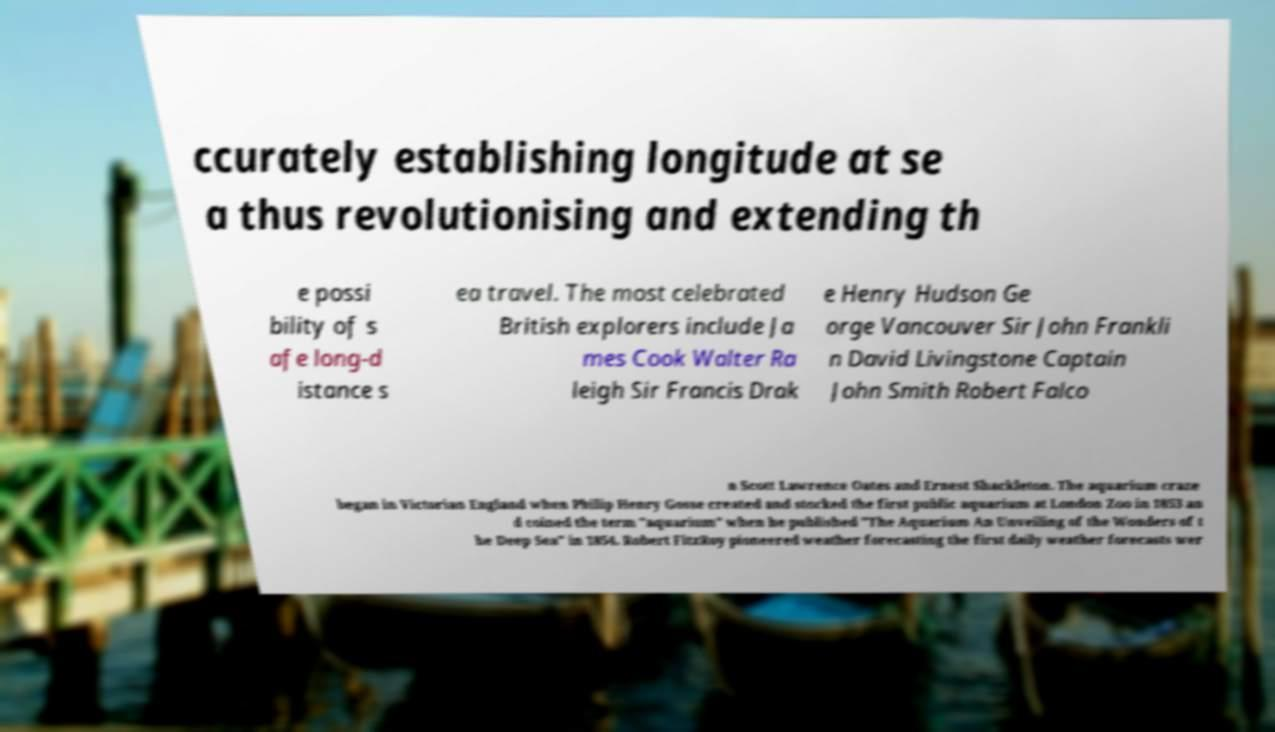Could you extract and type out the text from this image? ccurately establishing longitude at se a thus revolutionising and extending th e possi bility of s afe long-d istance s ea travel. The most celebrated British explorers include Ja mes Cook Walter Ra leigh Sir Francis Drak e Henry Hudson Ge orge Vancouver Sir John Frankli n David Livingstone Captain John Smith Robert Falco n Scott Lawrence Oates and Ernest Shackleton. The aquarium craze began in Victorian England when Philip Henry Gosse created and stocked the first public aquarium at London Zoo in 1853 an d coined the term "aquarium" when he published "The Aquarium An Unveiling of the Wonders of t he Deep Sea" in 1854. Robert FitzRoy pioneered weather forecasting the first daily weather forecasts wer 